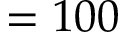<formula> <loc_0><loc_0><loc_500><loc_500>= 1 0 0</formula> 